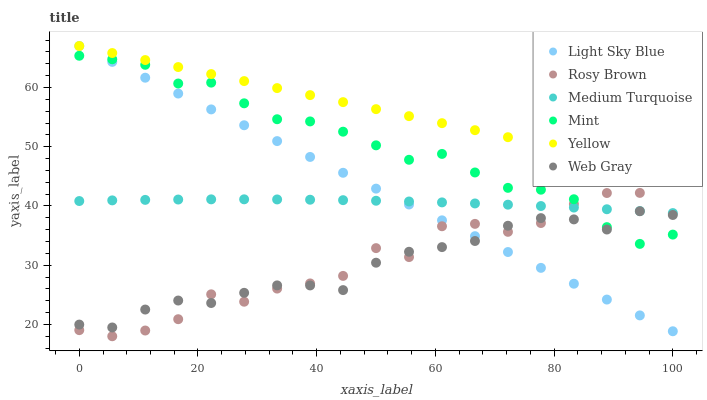Does Web Gray have the minimum area under the curve?
Answer yes or no. Yes. Does Yellow have the maximum area under the curve?
Answer yes or no. Yes. Does Rosy Brown have the minimum area under the curve?
Answer yes or no. No. Does Rosy Brown have the maximum area under the curve?
Answer yes or no. No. Is Yellow the smoothest?
Answer yes or no. Yes. Is Rosy Brown the roughest?
Answer yes or no. Yes. Is Rosy Brown the smoothest?
Answer yes or no. No. Is Yellow the roughest?
Answer yes or no. No. Does Rosy Brown have the lowest value?
Answer yes or no. Yes. Does Yellow have the lowest value?
Answer yes or no. No. Does Light Sky Blue have the highest value?
Answer yes or no. Yes. Does Rosy Brown have the highest value?
Answer yes or no. No. Is Mint less than Yellow?
Answer yes or no. Yes. Is Yellow greater than Medium Turquoise?
Answer yes or no. Yes. Does Web Gray intersect Mint?
Answer yes or no. Yes. Is Web Gray less than Mint?
Answer yes or no. No. Is Web Gray greater than Mint?
Answer yes or no. No. Does Mint intersect Yellow?
Answer yes or no. No. 